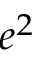Convert formula to latex. <formula><loc_0><loc_0><loc_500><loc_500>e ^ { 2 }</formula> 